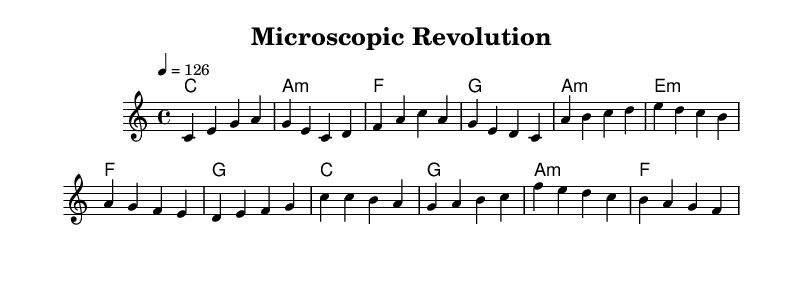What is the key signature of this music? The key signature indicates C major, which has no sharps or flats.
Answer: C major What is the time signature of this music? The time signature shown is 4/4, which means there are four beats in each measure.
Answer: 4/4 What is the tempo marking in this music? The tempo marking indicates a speed of 126 beats per minute, governed by the quarter note.
Answer: 126 How many sections does this composition have? The structure of the piece has three distinct sections: Verse, Pre-Chorus, and Chorus.
Answer: Three In which section do the lyrics emphasize medical breakthroughs? The lyrics discussing medical breakthroughs are most likely found in the Chorus, which typically contains key thematic elements.
Answer: Chorus What type of harmony is predominantly used in the verse? The harmony in the verse includes a major chord followed by a minor chord, indicating variation in mood and energy typical of pop music.
Answer: Major and minor What is the predominant mood conveyed by this piece of music? The overall mood is upbeat and energizing, typical of electropop, designed to evoke a sense of hope and excitement about scientific advances.
Answer: Upbeat 